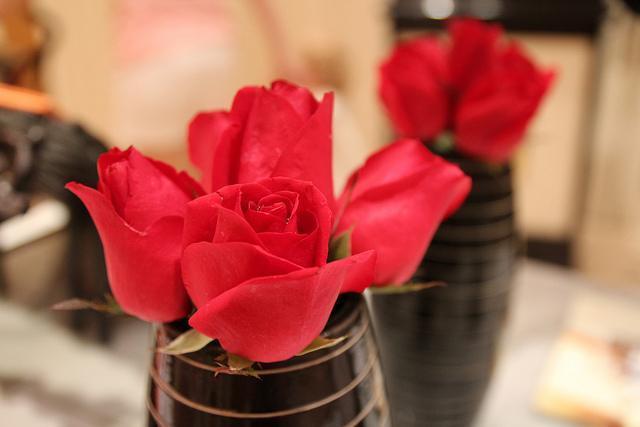How many vases can be seen?
Give a very brief answer. 2. 